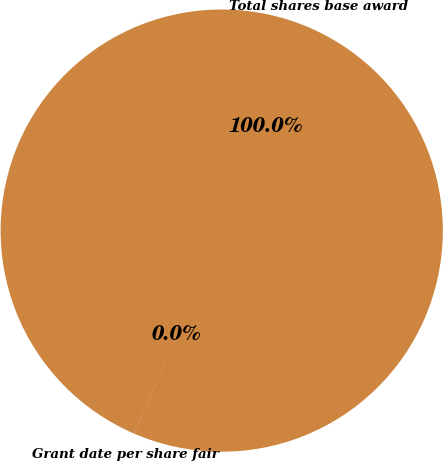<chart> <loc_0><loc_0><loc_500><loc_500><pie_chart><fcel>Total shares base award<fcel>Grant date per share fair<nl><fcel>99.99%<fcel>0.01%<nl></chart> 